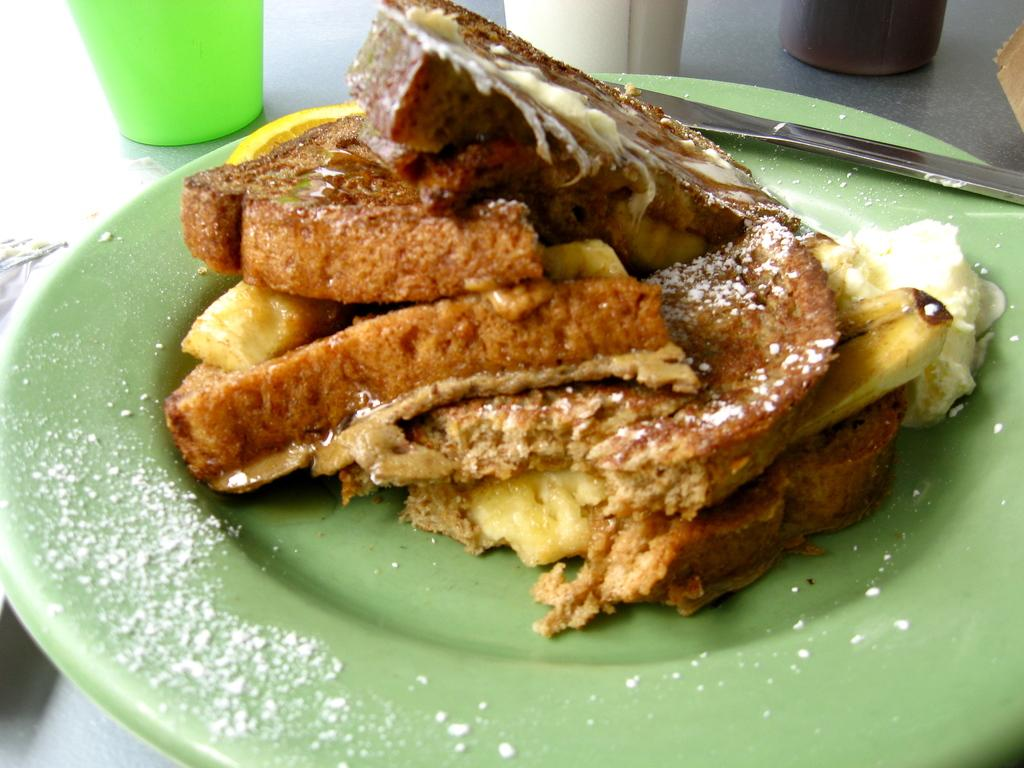What is on the plate that is visible in the image? There is a plate with food items in the image. What else can be seen on the table in the image? There are objects on the table in the image. What type of tax is being discussed in the image? There is no discussion of tax in the image; it features a plate with food items and objects on a table. How many boats are visible in the image? There are no boats present in the image. 